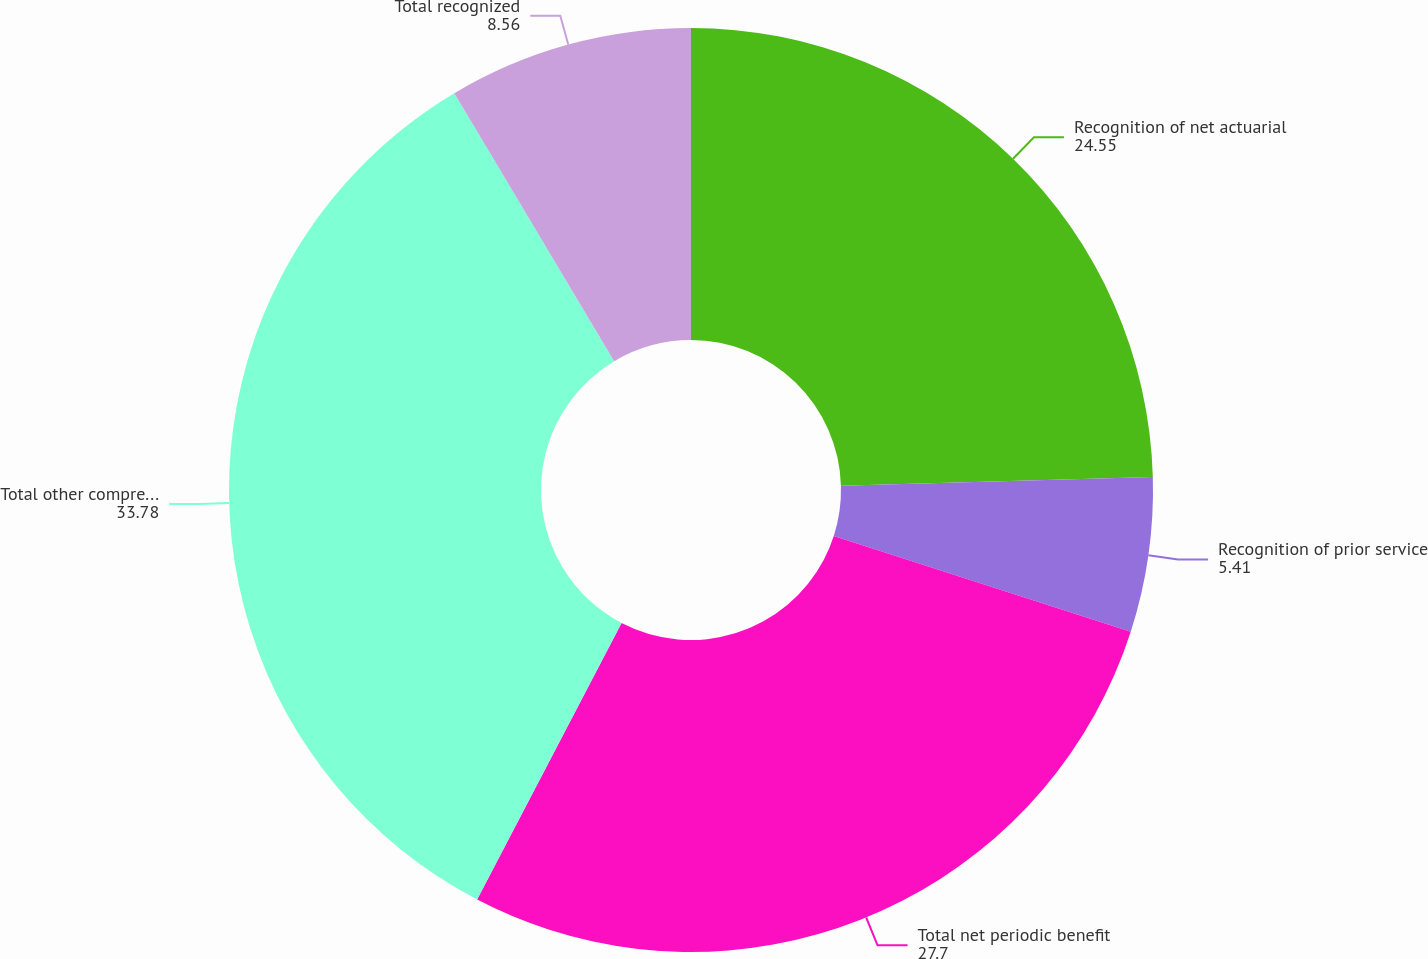Convert chart. <chart><loc_0><loc_0><loc_500><loc_500><pie_chart><fcel>Recognition of net actuarial<fcel>Recognition of prior service<fcel>Total net periodic benefit<fcel>Total other comprehensive loss<fcel>Total recognized<nl><fcel>24.55%<fcel>5.41%<fcel>27.7%<fcel>33.78%<fcel>8.56%<nl></chart> 